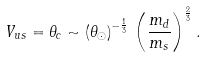<formula> <loc_0><loc_0><loc_500><loc_500>V _ { u s } = \theta _ { c } \sim \left ( \theta _ { \odot } \right ) ^ { - \frac { 1 } { 3 } } \, \left ( \frac { m _ { d } } { m _ { s } } \right ) ^ { \frac { 2 } { 3 } } .</formula> 